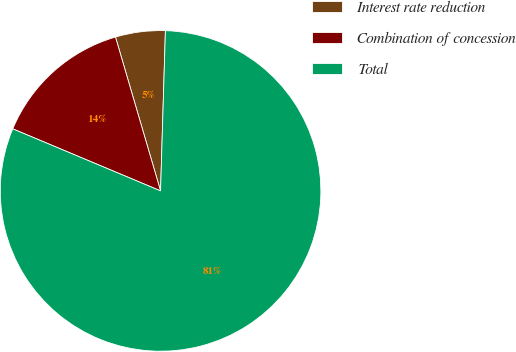<chart> <loc_0><loc_0><loc_500><loc_500><pie_chart><fcel>Interest rate reduction<fcel>Combination of concession<fcel>Total<nl><fcel>5.02%<fcel>14.14%<fcel>80.85%<nl></chart> 